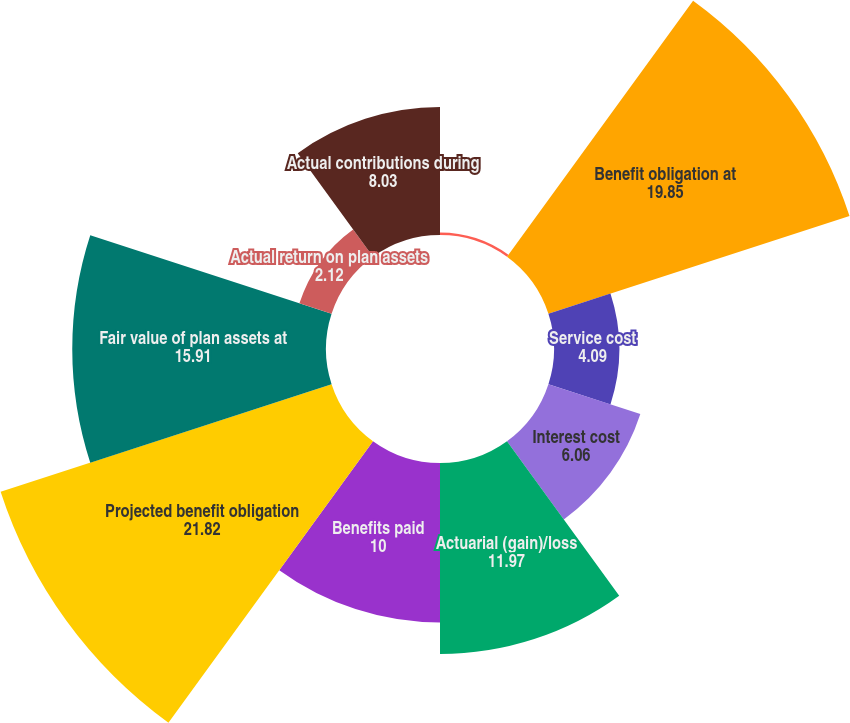Convert chart to OTSL. <chart><loc_0><loc_0><loc_500><loc_500><pie_chart><fcel>(Dollars in thousands)<fcel>Benefit obligation at<fcel>Service cost<fcel>Interest cost<fcel>Actuarial (gain)/loss<fcel>Benefits paid<fcel>Projected benefit obligation<fcel>Fair value of plan assets at<fcel>Actual return on plan assets<fcel>Actual contributions during<nl><fcel>0.15%<fcel>19.85%<fcel>4.09%<fcel>6.06%<fcel>11.97%<fcel>10.0%<fcel>21.82%<fcel>15.91%<fcel>2.12%<fcel>8.03%<nl></chart> 